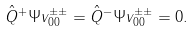<formula> <loc_0><loc_0><loc_500><loc_500>\hat { Q } ^ { + } \Psi v ^ { \pm \pm } _ { 0 0 } = \hat { Q } ^ { - } \Psi v ^ { \pm \pm } _ { 0 0 } = 0 .</formula> 